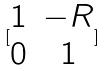<formula> <loc_0><loc_0><loc_500><loc_500>[ \begin{matrix} 1 & - R \\ 0 & 1 \end{matrix} ]</formula> 